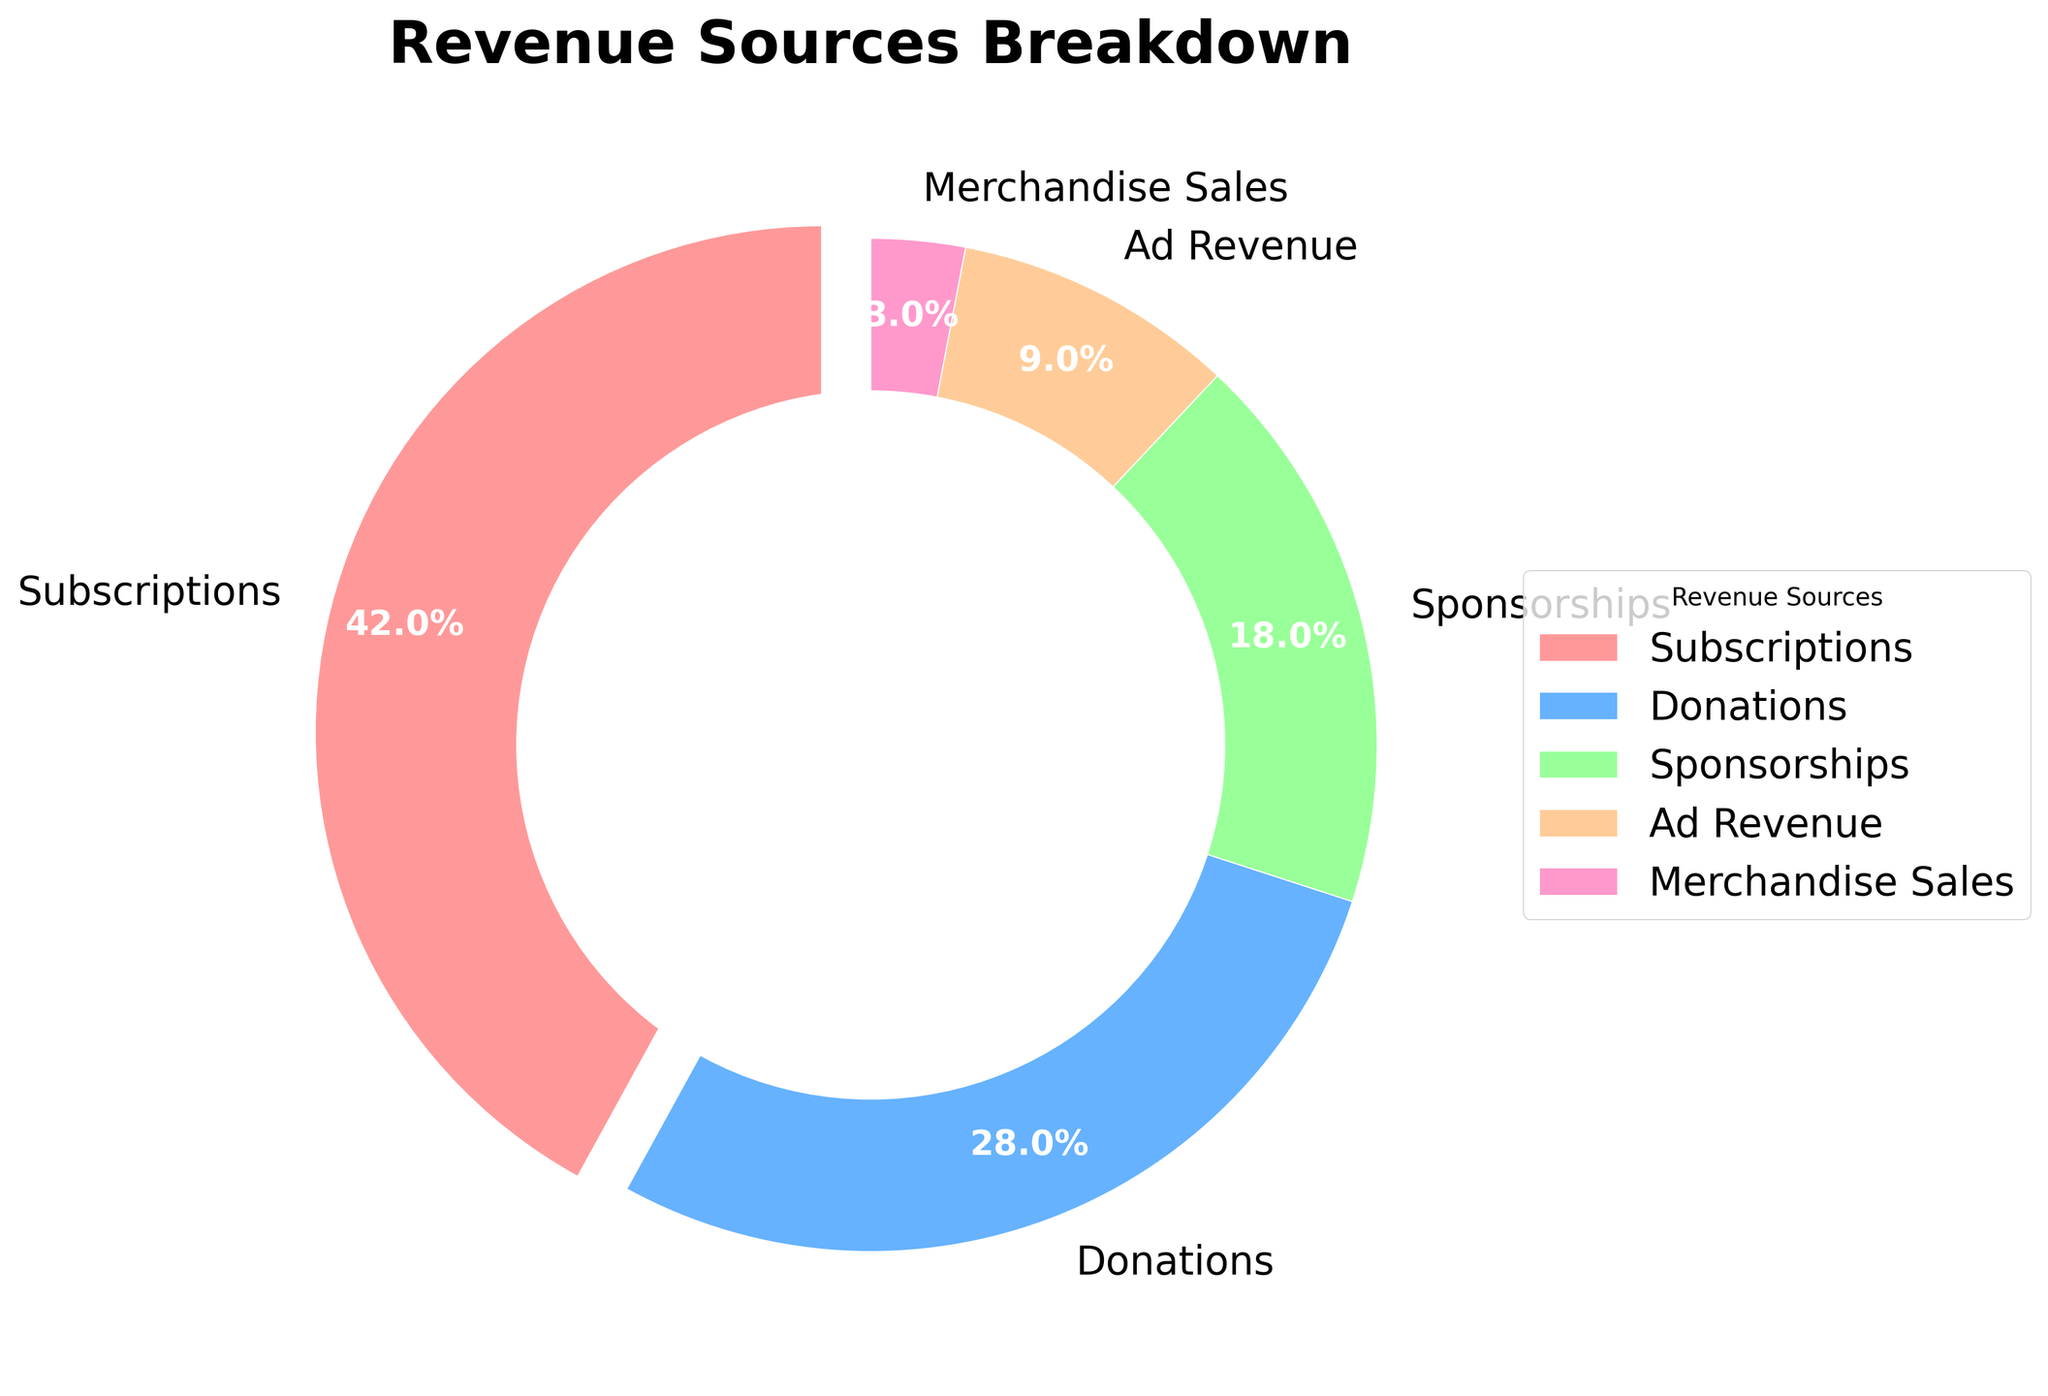What's the largest revenue source? The largest revenue source can be identified by looking at the segment with the highest percentage. In the pie chart, we see that 'Subscriptions' have the largest segment with 42%.
Answer: Subscriptions What percentage of total revenue comes from Donations and Ad Revenue combined? Add the percentages for Donations and Ad Revenue. Donations=28% and Ad Revenue=9%, so 28% + 9% = 37%.
Answer: 37% Which revenue source is depicted by the blue segment? The blue-colored segment corresponds to the 'Donations' revenue source as indicated in the chart legend.
Answer: Donations What is the difference in percentage between Subscriptions and Sponsorships? Subscriptions account for 42% and Sponsorships account for 18%. The difference can be computed as 42% - 18% = 24%.
Answer: 24% How many revenue sources have a percentage higher than 20%? By examining the segments in the pie chart, Subscriptions (42%) and Donations (28%) both exceed 20%.
Answer: 2 Is the percentage from Merchandise Sales larger or smaller than the percentage from Ad Revenue? Merchandise Sales at 3% is smaller than Ad Revenue at 9%, as indicated by their respective segment sizes.
Answer: Smaller What is the second smallest revenue source? The second smallest segment belongs to Ad Revenue with 9%, Merchandise Sales being the smallest with 3%.
Answer: Ad Revenue What is the total percentage from Sponsorships and Merchandise Sales combined? Adding the percentages for Sponsorships (18%) and Merchandise Sales (3%) gives 18% + 3% = 21%.
Answer: 21% If Subscriptions and Donations were combined into one category, what percentage would this new category represent? Subscriptions are 42% and Donations are 28%; their combination is 42% + 28% = 70%.
Answer: 70% Which revenue source constitutes the smallest portion of the revenue? The smallest segment is for Merchandise Sales with 3%.
Answer: Merchandise Sales 